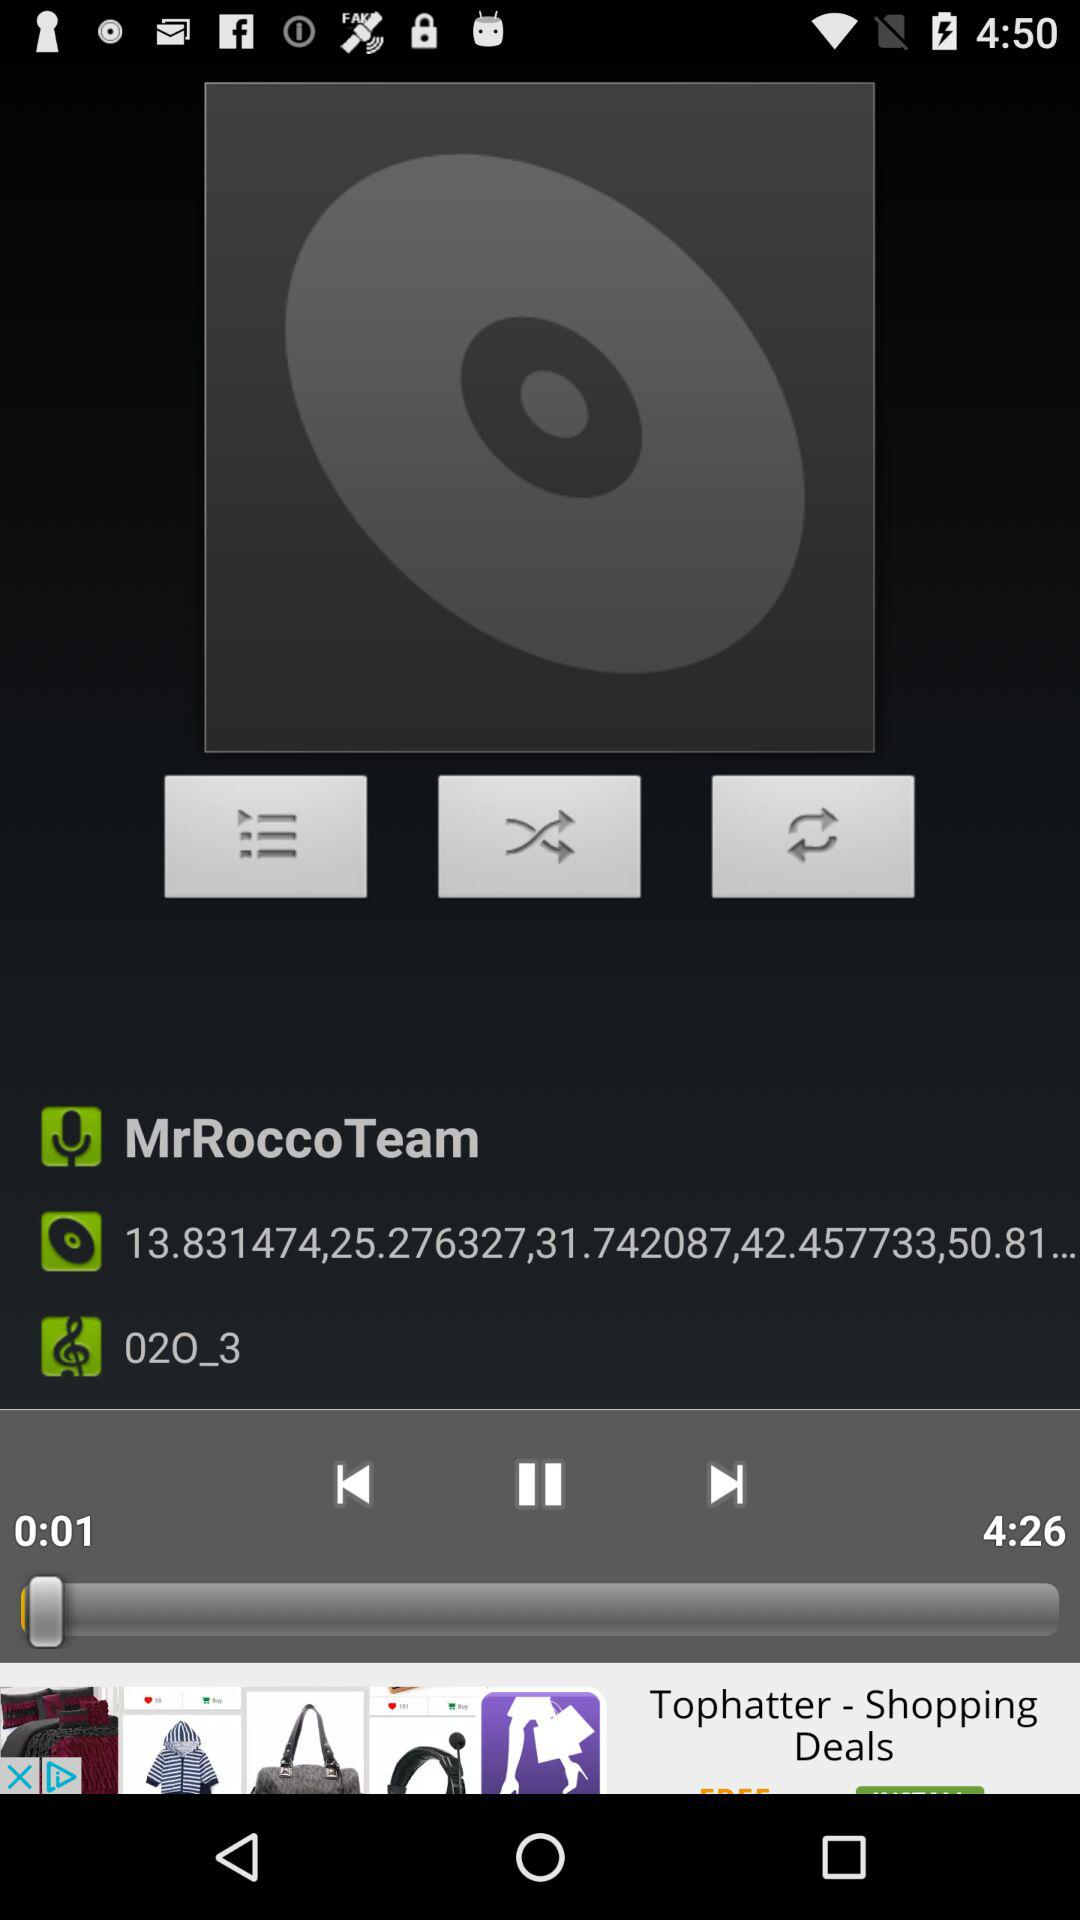What is the total duration of the audio? The total duration of the audio is 4 minutes 26 seconds. 